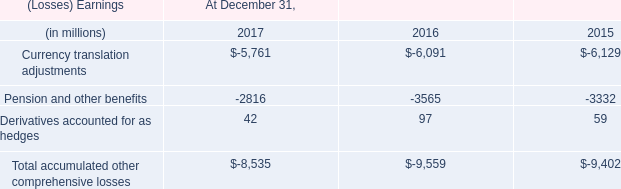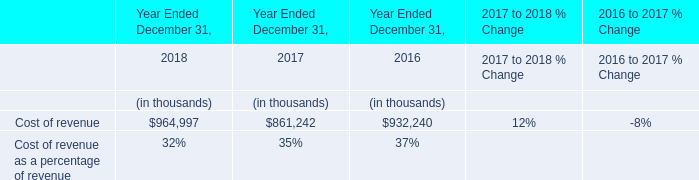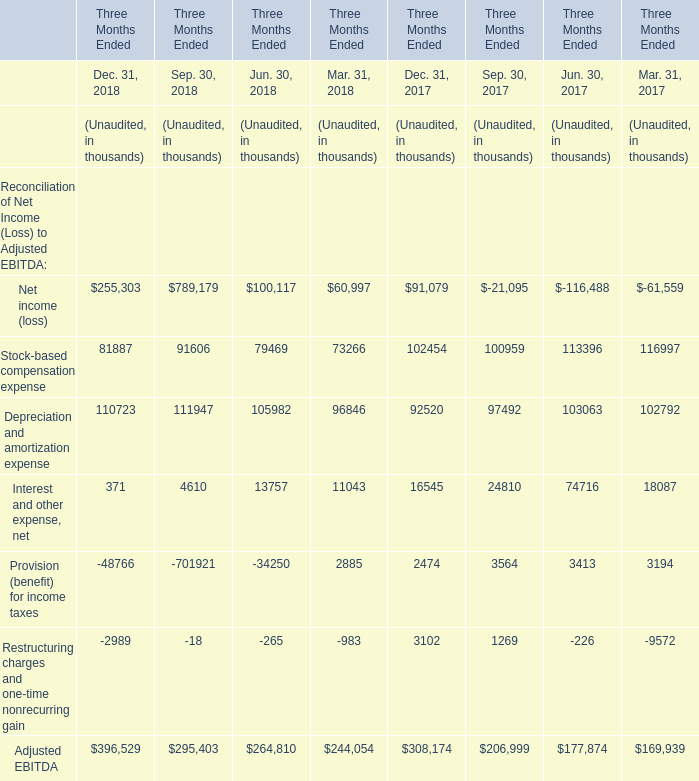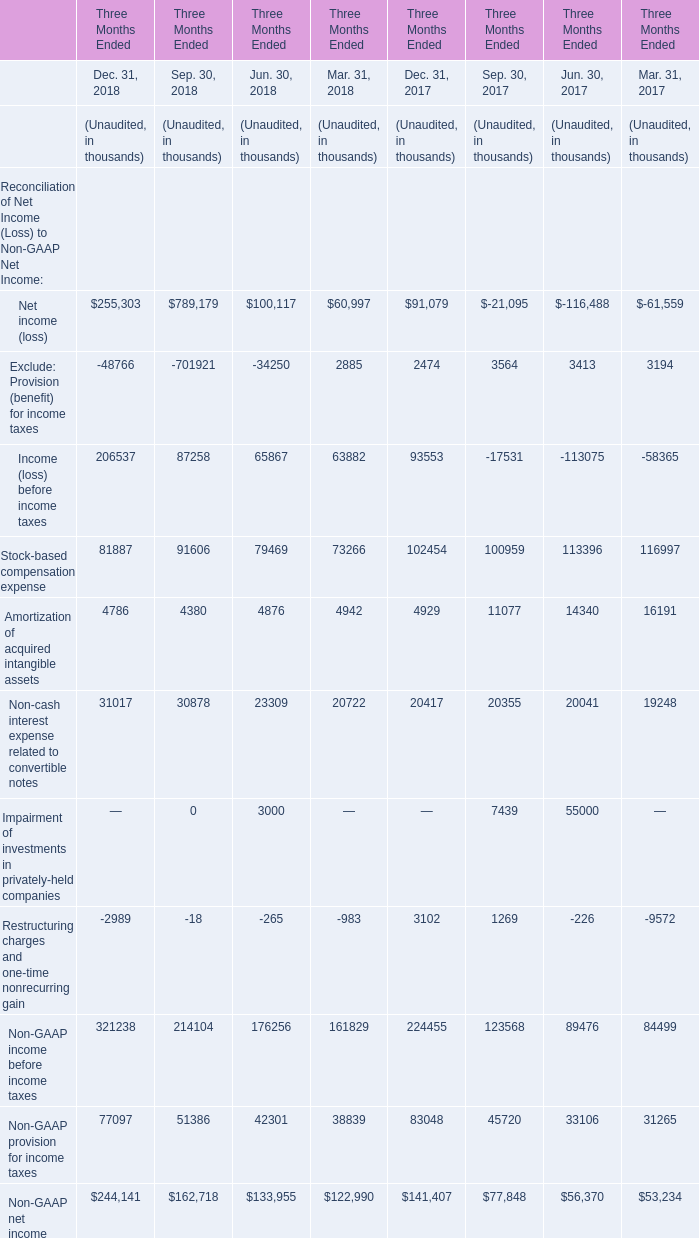What's the total value of all elements that are smaller than 100000 for Jun. 30, 2018? (in thousand) 
Computations: (((79469 + 13757) - 34250) - 265)
Answer: 58711.0. 